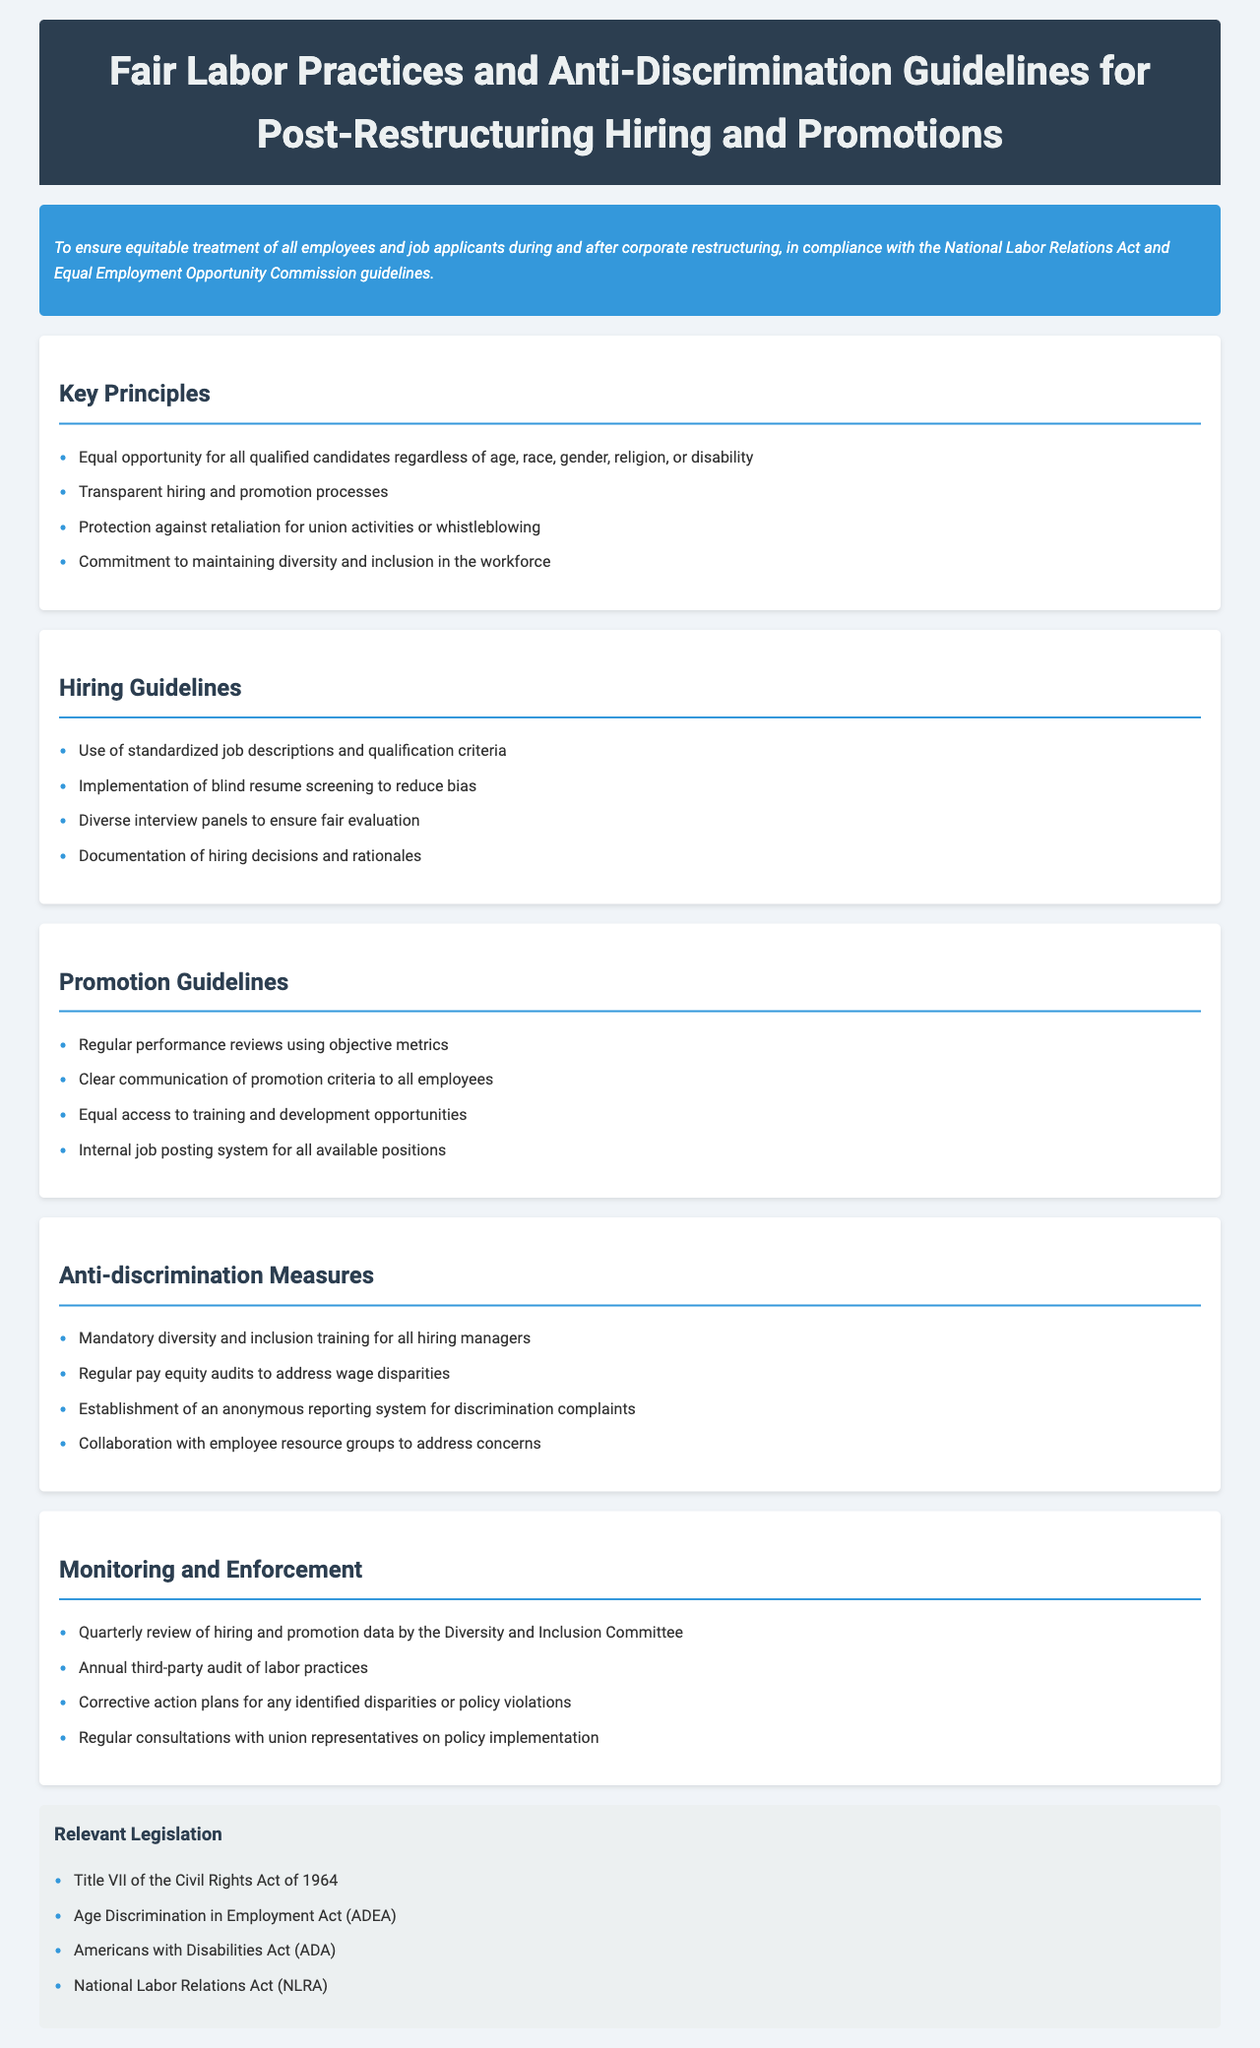What is the purpose of the guidelines? The purpose of the guidelines is to ensure equitable treatment of all employees and job applicants during and after corporate restructuring.
Answer: Equitable treatment of all employees and job applicants What are the key principles outlined in the document? The key principles are listed in the "Key Principles" section, focusing on equal opportunity and protection against retaliation.
Answer: Equal opportunity for all qualified candidates What does the hiring guideline suggest regarding resume screening? The hiring guidelines suggest the implementation of blind resume screening to reduce bias.
Answer: Blind resume screening What is one measure mentioned for addressing wage disparities? The document includes regular pay equity audits to address wage disparities under the anti-discrimination measures.
Answer: Pay equity audits How frequently will hiring and promotion data be reviewed? The monitoring and enforcement section states that hiring and promotion data will be reviewed quarterly.
Answer: Quarterly What act is mentioned as relevant legislation in the document? The document lists several acts as relevant legislation, including Title VII of the Civil Rights Act of 1964.
Answer: Title VII of the Civil Rights Act of 1964 What type of training is mandated for hiring managers? The anti-discrimination measures mandate mandatory diversity and inclusion training for all hiring managers.
Answer: Mandatory diversity and inclusion training What is one of the responsibilities of the Diversity and Inclusion Committee? The Diversity and Inclusion Committee is responsible for the quarterly review of hiring and promotion data.
Answer: Quarterly review of hiring and promotion data 